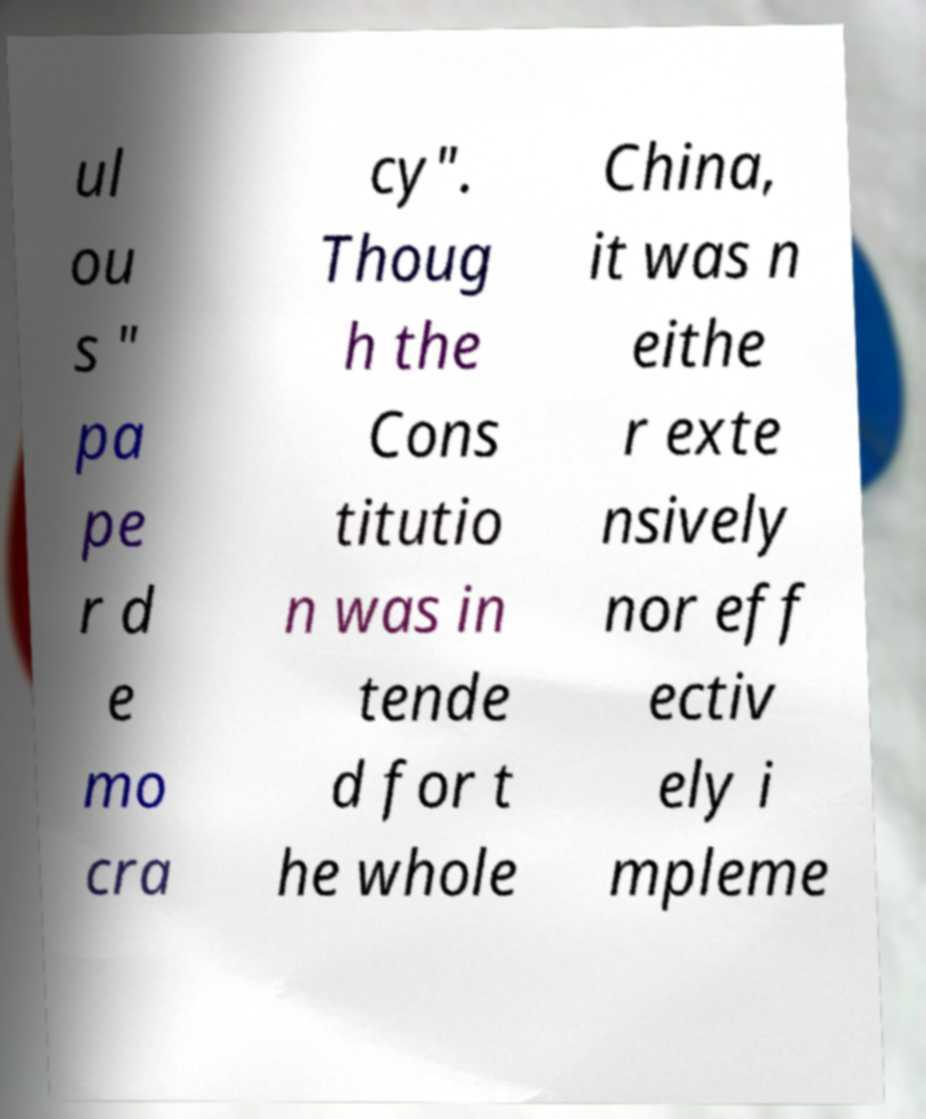Can you read and provide the text displayed in the image?This photo seems to have some interesting text. Can you extract and type it out for me? ul ou s " pa pe r d e mo cra cy". Thoug h the Cons titutio n was in tende d for t he whole China, it was n eithe r exte nsively nor eff ectiv ely i mpleme 